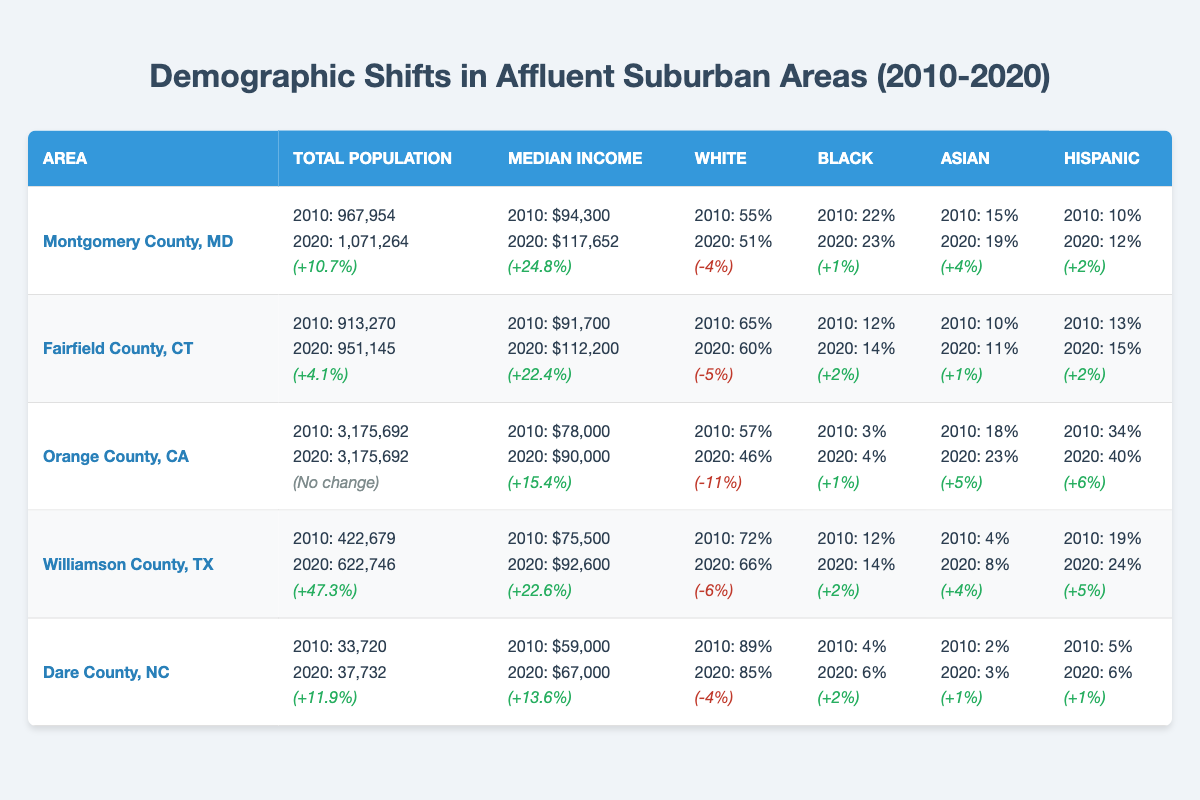What was the total population of Montgomery County, MD in 2020? According to the table, the total population for Montgomery County, MD in 2020 is listed under the "Total Population" column. It shows 1,071,264.
Answer: 1,071,264 What percentage of the population in Orange County, CA identified as Black in 2020? The table indicates that for Orange County, CA, the percentage of the population identifying as Black in 2020 is listed as 4%.
Answer: 4% How much did the median income increase in Fairfield County, CT from 2010 to 2020? The table shows the median income for Fairfield County, CT was $91,700 in 2010 and increased to $112,200 in 2020. To find the increase: $112,200 - $91,700 = $20,500.
Answer: $20,500 Which area experienced the highest percentage increase in total population from 2010 to 2020? The table shows the percentage increases for each area: Montgomery County (+10.7%), Fairfield County (+4.1%), Orange County (no change), Williamson County (+47.3%), and Dare County (+11.9%). Comparing these, Williamson County had the highest at +47.3%.
Answer: Williamson County, TX Did the percentage of White individuals in Williamson County, TX decrease from 2010 to 2020? The data in the table shows that the percentage of White individuals in Williamson County, TX decreased from 72% in 2010 to 66% in 2020, hence the answer is yes.
Answer: Yes What is the total percentage change for Hispanic individuals in Dare County, NC from 2010 to 2020? In 2010, the percentage of Hispanic individuals in Dare County, NC was 5%, and it increased to 6% in 2020. The change is 6% - 5% = 1%. Therefore, the total percentage change for Hispanic individuals is +1%.
Answer: +1% Compared to 2010, which area had a larger percentage increase in Asian population by 2020? From the table, in 2010 the Asian population percentages were: Montgomery (15% to 19%, +4%), Fairfield (10% to 11%, +1%), Orange (18% to 23%, +5%), Williamson (4% to 8%, +4%), and Dare (2% to 3%, +1%). Orange County had the highest increase at +5%.
Answer: Orange County, CA What was the total population of the areas listed in the table in 2010? The total populations were: Montgomery County (967,954), Fairfield County (913,270), Orange County (3,175,692), Williamson County (422,679), and Dare County (33,720). Adding these gives: 967,954 + 913,270 + 3,175,692 + 422,679 + 33,720 = 5,513,315.
Answer: 5,513,315 Was the median income higher in Montgomery County, MD or Williamson County, TX in 2020? The median income in 2020 for Montgomery County, MD is $117,652 and for Williamson County, TX it is $92,600 according to the table. Since $117,652 > $92,600, Montgomery County had a higher median income.
Answer: Montgomery County, MD 